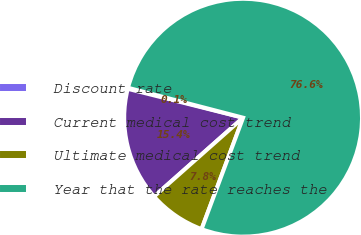<chart> <loc_0><loc_0><loc_500><loc_500><pie_chart><fcel>Discount rate<fcel>Current medical cost trend<fcel>Ultimate medical cost trend<fcel>Year that the rate reaches the<nl><fcel>0.14%<fcel>15.44%<fcel>7.79%<fcel>76.63%<nl></chart> 